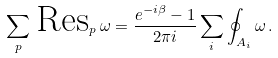Convert formula to latex. <formula><loc_0><loc_0><loc_500><loc_500>\sum _ { p } \, \text {Res} _ { p } \, \omega = \frac { e ^ { - i \beta } - 1 } { 2 \pi i } \sum _ { i } \oint _ { A _ { i } } \omega \, .</formula> 